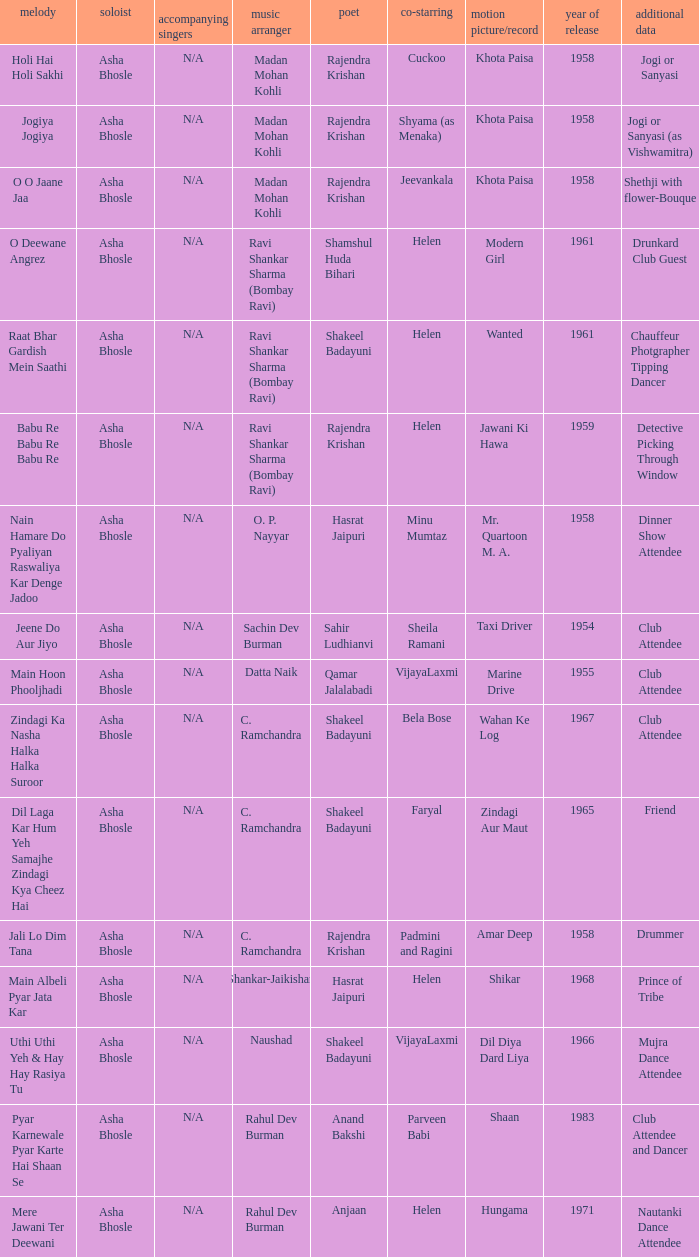How many co-performers were there when parveen babi co-starred? 1.0. 